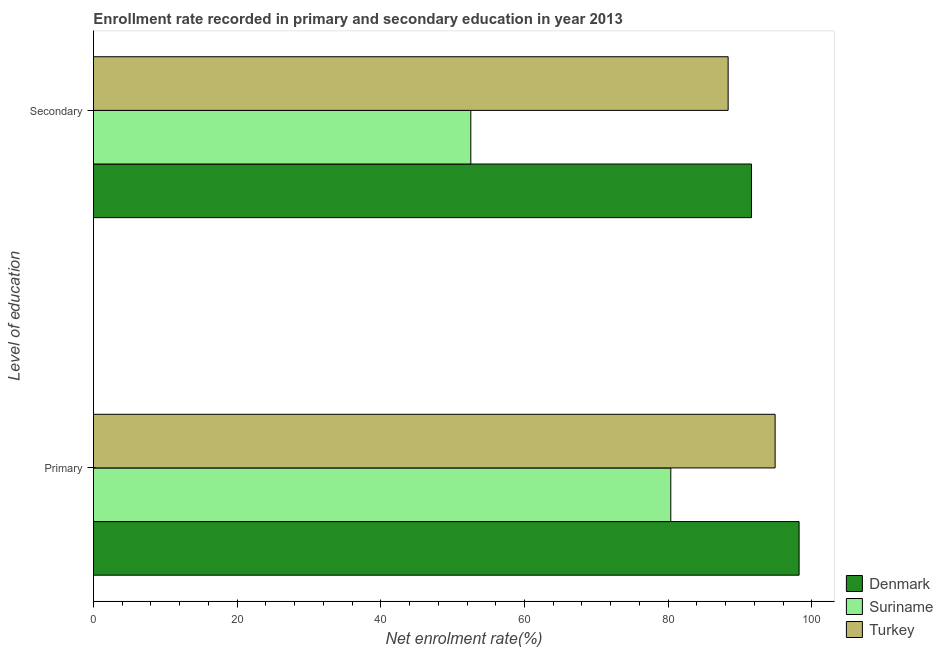How many different coloured bars are there?
Offer a terse response. 3. Are the number of bars per tick equal to the number of legend labels?
Give a very brief answer. Yes. How many bars are there on the 2nd tick from the top?
Offer a very short reply. 3. What is the label of the 2nd group of bars from the top?
Ensure brevity in your answer.  Primary. What is the enrollment rate in primary education in Denmark?
Ensure brevity in your answer.  98.22. Across all countries, what is the maximum enrollment rate in primary education?
Offer a terse response. 98.22. Across all countries, what is the minimum enrollment rate in secondary education?
Your response must be concise. 52.53. In which country was the enrollment rate in secondary education minimum?
Provide a short and direct response. Suriname. What is the total enrollment rate in primary education in the graph?
Give a very brief answer. 273.47. What is the difference between the enrollment rate in secondary education in Suriname and that in Turkey?
Keep it short and to the point. -35.82. What is the difference between the enrollment rate in primary education in Suriname and the enrollment rate in secondary education in Denmark?
Your response must be concise. -11.24. What is the average enrollment rate in secondary education per country?
Ensure brevity in your answer.  77.49. What is the difference between the enrollment rate in primary education and enrollment rate in secondary education in Suriname?
Make the answer very short. 27.84. In how many countries, is the enrollment rate in primary education greater than 56 %?
Give a very brief answer. 3. What is the ratio of the enrollment rate in primary education in Denmark to that in Suriname?
Offer a terse response. 1.22. What does the 1st bar from the top in Primary represents?
Your response must be concise. Turkey. What does the 1st bar from the bottom in Secondary represents?
Make the answer very short. Denmark. How many countries are there in the graph?
Provide a succinct answer. 3. Are the values on the major ticks of X-axis written in scientific E-notation?
Offer a very short reply. No. Does the graph contain grids?
Give a very brief answer. No. How are the legend labels stacked?
Keep it short and to the point. Vertical. What is the title of the graph?
Give a very brief answer. Enrollment rate recorded in primary and secondary education in year 2013. Does "Lower middle income" appear as one of the legend labels in the graph?
Offer a terse response. No. What is the label or title of the X-axis?
Your answer should be very brief. Net enrolment rate(%). What is the label or title of the Y-axis?
Make the answer very short. Level of education. What is the Net enrolment rate(%) in Denmark in Primary?
Offer a very short reply. 98.22. What is the Net enrolment rate(%) of Suriname in Primary?
Provide a succinct answer. 80.36. What is the Net enrolment rate(%) of Turkey in Primary?
Provide a short and direct response. 94.88. What is the Net enrolment rate(%) of Denmark in Secondary?
Give a very brief answer. 91.6. What is the Net enrolment rate(%) of Suriname in Secondary?
Make the answer very short. 52.53. What is the Net enrolment rate(%) in Turkey in Secondary?
Keep it short and to the point. 88.34. Across all Level of education, what is the maximum Net enrolment rate(%) of Denmark?
Your response must be concise. 98.22. Across all Level of education, what is the maximum Net enrolment rate(%) in Suriname?
Provide a short and direct response. 80.36. Across all Level of education, what is the maximum Net enrolment rate(%) of Turkey?
Offer a very short reply. 94.88. Across all Level of education, what is the minimum Net enrolment rate(%) of Denmark?
Your answer should be very brief. 91.6. Across all Level of education, what is the minimum Net enrolment rate(%) in Suriname?
Ensure brevity in your answer.  52.53. Across all Level of education, what is the minimum Net enrolment rate(%) of Turkey?
Offer a very short reply. 88.34. What is the total Net enrolment rate(%) of Denmark in the graph?
Offer a very short reply. 189.82. What is the total Net enrolment rate(%) in Suriname in the graph?
Your answer should be compact. 132.89. What is the total Net enrolment rate(%) of Turkey in the graph?
Offer a terse response. 183.23. What is the difference between the Net enrolment rate(%) of Denmark in Primary and that in Secondary?
Your answer should be compact. 6.62. What is the difference between the Net enrolment rate(%) in Suriname in Primary and that in Secondary?
Provide a short and direct response. 27.84. What is the difference between the Net enrolment rate(%) of Turkey in Primary and that in Secondary?
Offer a terse response. 6.54. What is the difference between the Net enrolment rate(%) of Denmark in Primary and the Net enrolment rate(%) of Suriname in Secondary?
Provide a short and direct response. 45.7. What is the difference between the Net enrolment rate(%) of Denmark in Primary and the Net enrolment rate(%) of Turkey in Secondary?
Give a very brief answer. 9.88. What is the difference between the Net enrolment rate(%) in Suriname in Primary and the Net enrolment rate(%) in Turkey in Secondary?
Your answer should be very brief. -7.98. What is the average Net enrolment rate(%) of Denmark per Level of education?
Provide a succinct answer. 94.91. What is the average Net enrolment rate(%) in Suriname per Level of education?
Your response must be concise. 66.44. What is the average Net enrolment rate(%) of Turkey per Level of education?
Make the answer very short. 91.61. What is the difference between the Net enrolment rate(%) in Denmark and Net enrolment rate(%) in Suriname in Primary?
Your answer should be compact. 17.86. What is the difference between the Net enrolment rate(%) in Denmark and Net enrolment rate(%) in Turkey in Primary?
Provide a succinct answer. 3.34. What is the difference between the Net enrolment rate(%) of Suriname and Net enrolment rate(%) of Turkey in Primary?
Give a very brief answer. -14.52. What is the difference between the Net enrolment rate(%) in Denmark and Net enrolment rate(%) in Suriname in Secondary?
Provide a succinct answer. 39.07. What is the difference between the Net enrolment rate(%) of Denmark and Net enrolment rate(%) of Turkey in Secondary?
Give a very brief answer. 3.25. What is the difference between the Net enrolment rate(%) of Suriname and Net enrolment rate(%) of Turkey in Secondary?
Offer a very short reply. -35.82. What is the ratio of the Net enrolment rate(%) of Denmark in Primary to that in Secondary?
Provide a succinct answer. 1.07. What is the ratio of the Net enrolment rate(%) in Suriname in Primary to that in Secondary?
Provide a succinct answer. 1.53. What is the ratio of the Net enrolment rate(%) of Turkey in Primary to that in Secondary?
Your answer should be compact. 1.07. What is the difference between the highest and the second highest Net enrolment rate(%) of Denmark?
Keep it short and to the point. 6.62. What is the difference between the highest and the second highest Net enrolment rate(%) of Suriname?
Provide a short and direct response. 27.84. What is the difference between the highest and the second highest Net enrolment rate(%) of Turkey?
Ensure brevity in your answer.  6.54. What is the difference between the highest and the lowest Net enrolment rate(%) in Denmark?
Offer a very short reply. 6.62. What is the difference between the highest and the lowest Net enrolment rate(%) of Suriname?
Offer a terse response. 27.84. What is the difference between the highest and the lowest Net enrolment rate(%) of Turkey?
Give a very brief answer. 6.54. 